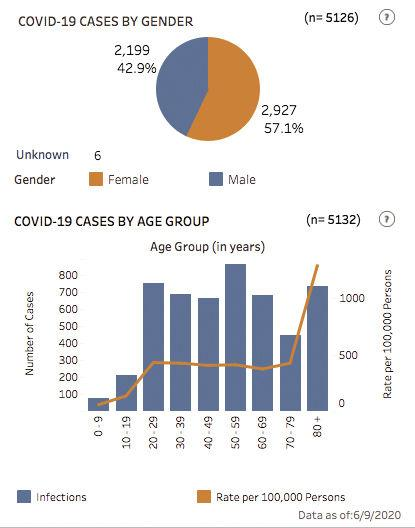Draw attention to some important aspects in this diagram. The age group of 50-59 has had the most number of cases. The reported number of Covid-19 cases among females is 14.2% higher than among males. Female group reports more cases if looked at on a gender basis. The second smallest number of cases was reported in the age group of 10-19. The 20-29 age group has had the second highest number of cases. 